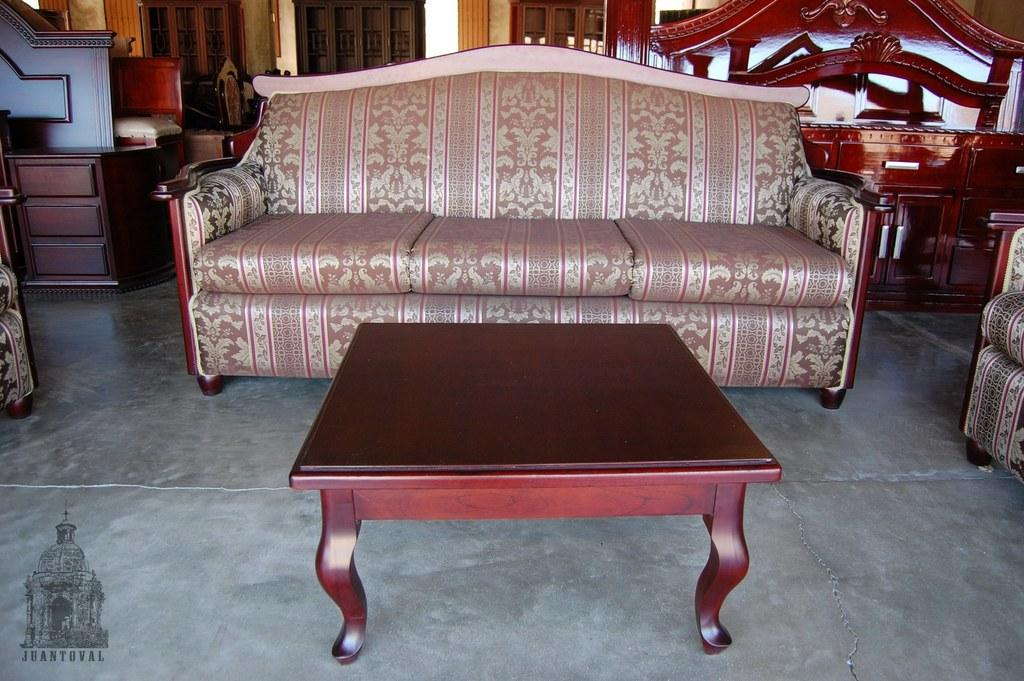What color is the sofa in the image? The sofa in the image is light pink. What is located in front of the sofa? There is a table in front of the sofa. Can you describe the furniture visible in the background of the image? There are many pieces of furniture visible in the background of the image. How much has the plant grown in the image since it was first placed on the bucket? There is no plant or bucket present in the image, so it is not possible to determine any growth or changes. 